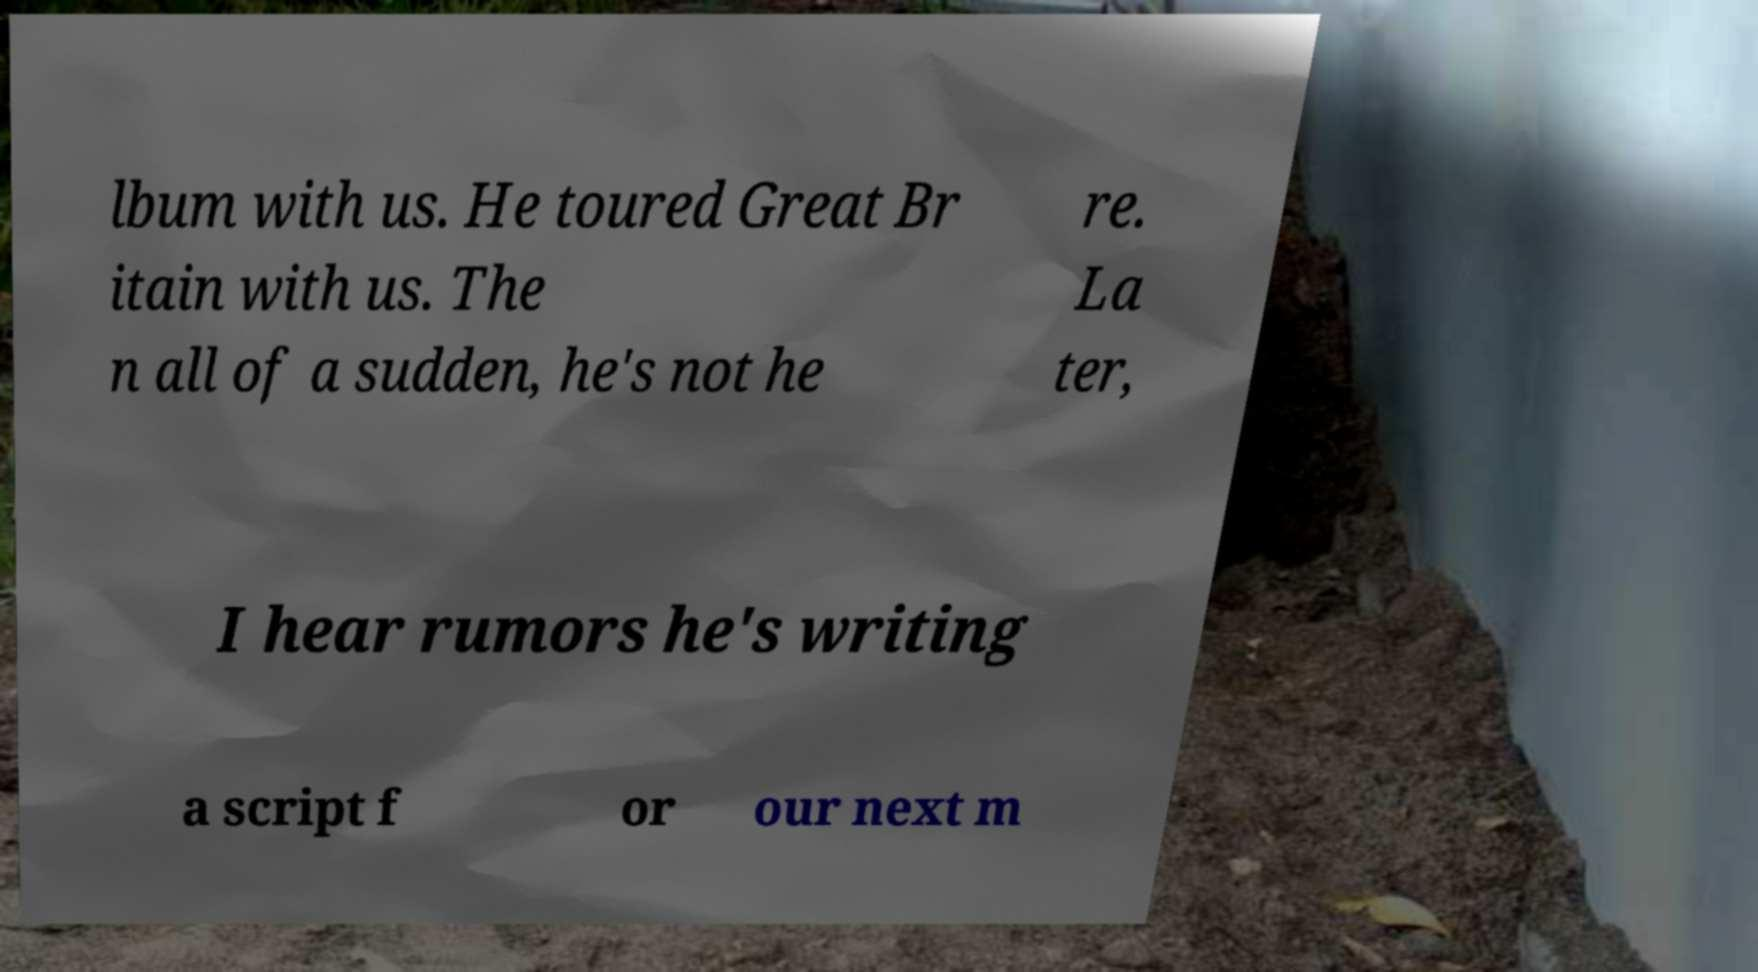For documentation purposes, I need the text within this image transcribed. Could you provide that? lbum with us. He toured Great Br itain with us. The n all of a sudden, he's not he re. La ter, I hear rumors he's writing a script f or our next m 